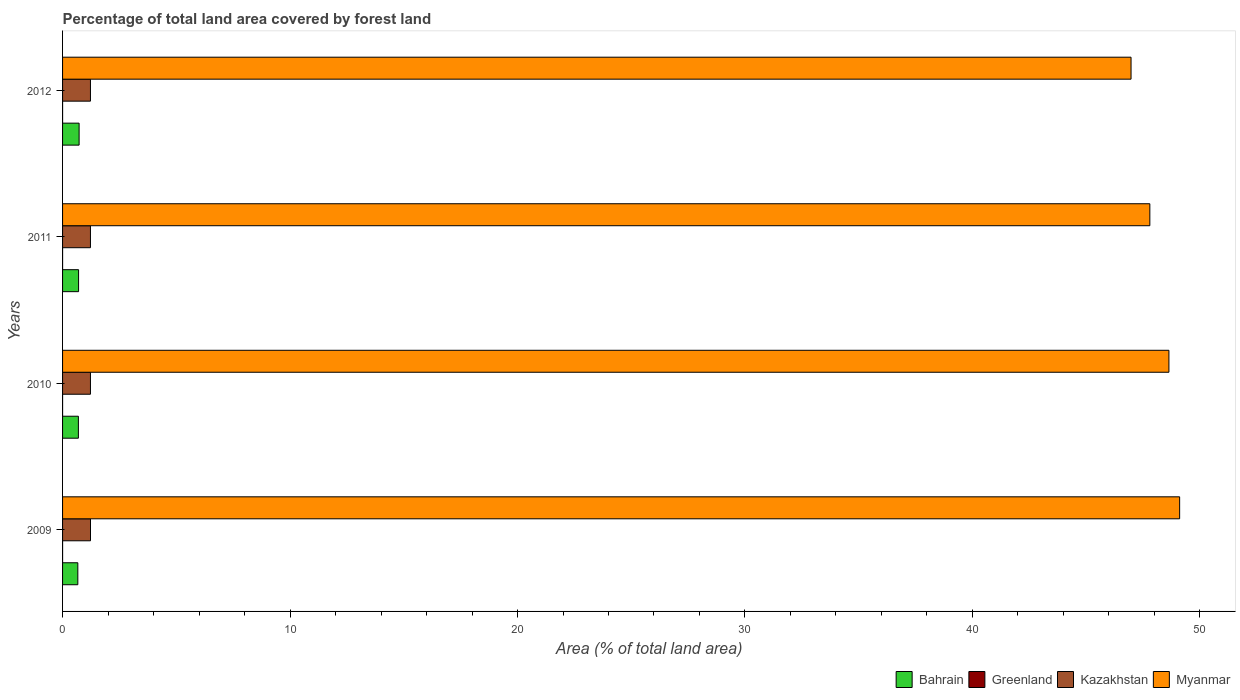How many different coloured bars are there?
Give a very brief answer. 4. How many bars are there on the 2nd tick from the top?
Provide a short and direct response. 4. How many bars are there on the 3rd tick from the bottom?
Give a very brief answer. 4. In how many cases, is the number of bars for a given year not equal to the number of legend labels?
Your answer should be very brief. 0. What is the percentage of forest land in Greenland in 2009?
Your answer should be compact. 0. Across all years, what is the maximum percentage of forest land in Myanmar?
Your response must be concise. 49.11. Across all years, what is the minimum percentage of forest land in Greenland?
Provide a short and direct response. 0. In which year was the percentage of forest land in Greenland maximum?
Offer a very short reply. 2009. What is the total percentage of forest land in Myanmar in the graph?
Give a very brief answer. 192.52. What is the difference between the percentage of forest land in Myanmar in 2009 and that in 2010?
Offer a very short reply. 0.47. What is the difference between the percentage of forest land in Greenland in 2011 and the percentage of forest land in Myanmar in 2012?
Offer a terse response. -46.97. What is the average percentage of forest land in Kazakhstan per year?
Your answer should be compact. 1.23. In the year 2009, what is the difference between the percentage of forest land in Kazakhstan and percentage of forest land in Bahrain?
Provide a succinct answer. 0.56. In how many years, is the percentage of forest land in Kazakhstan greater than 34 %?
Your response must be concise. 0. What is the ratio of the percentage of forest land in Bahrain in 2010 to that in 2011?
Your answer should be very brief. 0.99. What is the difference between the highest and the second highest percentage of forest land in Bahrain?
Keep it short and to the point. 0.02. What is the difference between the highest and the lowest percentage of forest land in Myanmar?
Keep it short and to the point. 2.14. Is it the case that in every year, the sum of the percentage of forest land in Bahrain and percentage of forest land in Kazakhstan is greater than the sum of percentage of forest land in Myanmar and percentage of forest land in Greenland?
Give a very brief answer. Yes. What does the 2nd bar from the top in 2009 represents?
Ensure brevity in your answer.  Kazakhstan. What does the 3rd bar from the bottom in 2011 represents?
Ensure brevity in your answer.  Kazakhstan. Is it the case that in every year, the sum of the percentage of forest land in Kazakhstan and percentage of forest land in Myanmar is greater than the percentage of forest land in Greenland?
Provide a succinct answer. Yes. How many years are there in the graph?
Your answer should be very brief. 4. What is the difference between two consecutive major ticks on the X-axis?
Give a very brief answer. 10. Are the values on the major ticks of X-axis written in scientific E-notation?
Provide a succinct answer. No. Does the graph contain any zero values?
Keep it short and to the point. No. Where does the legend appear in the graph?
Make the answer very short. Bottom right. How many legend labels are there?
Offer a terse response. 4. How are the legend labels stacked?
Make the answer very short. Horizontal. What is the title of the graph?
Make the answer very short. Percentage of total land area covered by forest land. What is the label or title of the X-axis?
Your answer should be compact. Area (% of total land area). What is the label or title of the Y-axis?
Offer a very short reply. Years. What is the Area (% of total land area) of Bahrain in 2009?
Give a very brief answer. 0.67. What is the Area (% of total land area) of Greenland in 2009?
Offer a terse response. 0. What is the Area (% of total land area) in Kazakhstan in 2009?
Offer a very short reply. 1.23. What is the Area (% of total land area) of Myanmar in 2009?
Your answer should be compact. 49.11. What is the Area (% of total land area) of Bahrain in 2010?
Provide a short and direct response. 0.7. What is the Area (% of total land area) in Greenland in 2010?
Make the answer very short. 0. What is the Area (% of total land area) of Kazakhstan in 2010?
Your answer should be very brief. 1.23. What is the Area (% of total land area) in Myanmar in 2010?
Provide a succinct answer. 48.64. What is the Area (% of total land area) of Bahrain in 2011?
Offer a very short reply. 0.7. What is the Area (% of total land area) of Greenland in 2011?
Make the answer very short. 0. What is the Area (% of total land area) in Kazakhstan in 2011?
Your answer should be compact. 1.23. What is the Area (% of total land area) in Myanmar in 2011?
Offer a terse response. 47.8. What is the Area (% of total land area) of Bahrain in 2012?
Offer a very short reply. 0.73. What is the Area (% of total land area) of Greenland in 2012?
Your response must be concise. 0. What is the Area (% of total land area) of Kazakhstan in 2012?
Make the answer very short. 1.23. What is the Area (% of total land area) in Myanmar in 2012?
Your answer should be compact. 46.97. Across all years, what is the maximum Area (% of total land area) in Bahrain?
Offer a very short reply. 0.73. Across all years, what is the maximum Area (% of total land area) in Greenland?
Your answer should be very brief. 0. Across all years, what is the maximum Area (% of total land area) of Kazakhstan?
Your answer should be compact. 1.23. Across all years, what is the maximum Area (% of total land area) in Myanmar?
Offer a very short reply. 49.11. Across all years, what is the minimum Area (% of total land area) in Bahrain?
Offer a very short reply. 0.67. Across all years, what is the minimum Area (% of total land area) in Greenland?
Your response must be concise. 0. Across all years, what is the minimum Area (% of total land area) in Kazakhstan?
Offer a terse response. 1.23. Across all years, what is the minimum Area (% of total land area) in Myanmar?
Offer a terse response. 46.97. What is the total Area (% of total land area) of Bahrain in the graph?
Offer a terse response. 2.8. What is the total Area (% of total land area) of Greenland in the graph?
Give a very brief answer. 0. What is the total Area (% of total land area) of Kazakhstan in the graph?
Offer a very short reply. 4.9. What is the total Area (% of total land area) in Myanmar in the graph?
Provide a succinct answer. 192.52. What is the difference between the Area (% of total land area) of Bahrain in 2009 and that in 2010?
Your answer should be compact. -0.02. What is the difference between the Area (% of total land area) of Kazakhstan in 2009 and that in 2010?
Give a very brief answer. 0. What is the difference between the Area (% of total land area) of Myanmar in 2009 and that in 2010?
Offer a terse response. 0.47. What is the difference between the Area (% of total land area) of Bahrain in 2009 and that in 2011?
Offer a terse response. -0.03. What is the difference between the Area (% of total land area) in Greenland in 2009 and that in 2011?
Provide a short and direct response. 0. What is the difference between the Area (% of total land area) in Kazakhstan in 2009 and that in 2011?
Ensure brevity in your answer.  0. What is the difference between the Area (% of total land area) in Myanmar in 2009 and that in 2011?
Your response must be concise. 1.31. What is the difference between the Area (% of total land area) of Bahrain in 2009 and that in 2012?
Your response must be concise. -0.06. What is the difference between the Area (% of total land area) of Greenland in 2009 and that in 2012?
Offer a very short reply. 0. What is the difference between the Area (% of total land area) of Kazakhstan in 2009 and that in 2012?
Your answer should be very brief. 0. What is the difference between the Area (% of total land area) of Myanmar in 2009 and that in 2012?
Keep it short and to the point. 2.14. What is the difference between the Area (% of total land area) of Bahrain in 2010 and that in 2011?
Your answer should be compact. -0.01. What is the difference between the Area (% of total land area) in Greenland in 2010 and that in 2011?
Offer a very short reply. 0. What is the difference between the Area (% of total land area) of Kazakhstan in 2010 and that in 2011?
Your response must be concise. 0. What is the difference between the Area (% of total land area) of Myanmar in 2010 and that in 2011?
Give a very brief answer. 0.84. What is the difference between the Area (% of total land area) in Bahrain in 2010 and that in 2012?
Your response must be concise. -0.03. What is the difference between the Area (% of total land area) of Kazakhstan in 2010 and that in 2012?
Ensure brevity in your answer.  0. What is the difference between the Area (% of total land area) in Myanmar in 2010 and that in 2012?
Your response must be concise. 1.66. What is the difference between the Area (% of total land area) of Bahrain in 2011 and that in 2012?
Ensure brevity in your answer.  -0.02. What is the difference between the Area (% of total land area) in Greenland in 2011 and that in 2012?
Your response must be concise. 0. What is the difference between the Area (% of total land area) in Kazakhstan in 2011 and that in 2012?
Your answer should be very brief. 0. What is the difference between the Area (% of total land area) of Myanmar in 2011 and that in 2012?
Ensure brevity in your answer.  0.83. What is the difference between the Area (% of total land area) of Bahrain in 2009 and the Area (% of total land area) of Greenland in 2010?
Your response must be concise. 0.67. What is the difference between the Area (% of total land area) in Bahrain in 2009 and the Area (% of total land area) in Kazakhstan in 2010?
Provide a short and direct response. -0.55. What is the difference between the Area (% of total land area) of Bahrain in 2009 and the Area (% of total land area) of Myanmar in 2010?
Your response must be concise. -47.97. What is the difference between the Area (% of total land area) in Greenland in 2009 and the Area (% of total land area) in Kazakhstan in 2010?
Your answer should be very brief. -1.23. What is the difference between the Area (% of total land area) of Greenland in 2009 and the Area (% of total land area) of Myanmar in 2010?
Provide a short and direct response. -48.64. What is the difference between the Area (% of total land area) of Kazakhstan in 2009 and the Area (% of total land area) of Myanmar in 2010?
Make the answer very short. -47.41. What is the difference between the Area (% of total land area) in Bahrain in 2009 and the Area (% of total land area) in Greenland in 2011?
Your answer should be very brief. 0.67. What is the difference between the Area (% of total land area) in Bahrain in 2009 and the Area (% of total land area) in Kazakhstan in 2011?
Provide a short and direct response. -0.55. What is the difference between the Area (% of total land area) of Bahrain in 2009 and the Area (% of total land area) of Myanmar in 2011?
Make the answer very short. -47.13. What is the difference between the Area (% of total land area) in Greenland in 2009 and the Area (% of total land area) in Kazakhstan in 2011?
Offer a very short reply. -1.23. What is the difference between the Area (% of total land area) of Greenland in 2009 and the Area (% of total land area) of Myanmar in 2011?
Your response must be concise. -47.8. What is the difference between the Area (% of total land area) in Kazakhstan in 2009 and the Area (% of total land area) in Myanmar in 2011?
Your answer should be very brief. -46.57. What is the difference between the Area (% of total land area) of Bahrain in 2009 and the Area (% of total land area) of Greenland in 2012?
Offer a very short reply. 0.67. What is the difference between the Area (% of total land area) of Bahrain in 2009 and the Area (% of total land area) of Kazakhstan in 2012?
Ensure brevity in your answer.  -0.55. What is the difference between the Area (% of total land area) of Bahrain in 2009 and the Area (% of total land area) of Myanmar in 2012?
Make the answer very short. -46.3. What is the difference between the Area (% of total land area) of Greenland in 2009 and the Area (% of total land area) of Kazakhstan in 2012?
Keep it short and to the point. -1.23. What is the difference between the Area (% of total land area) in Greenland in 2009 and the Area (% of total land area) in Myanmar in 2012?
Provide a short and direct response. -46.97. What is the difference between the Area (% of total land area) of Kazakhstan in 2009 and the Area (% of total land area) of Myanmar in 2012?
Ensure brevity in your answer.  -45.74. What is the difference between the Area (% of total land area) of Bahrain in 2010 and the Area (% of total land area) of Greenland in 2011?
Give a very brief answer. 0.69. What is the difference between the Area (% of total land area) in Bahrain in 2010 and the Area (% of total land area) in Kazakhstan in 2011?
Offer a very short reply. -0.53. What is the difference between the Area (% of total land area) in Bahrain in 2010 and the Area (% of total land area) in Myanmar in 2011?
Your response must be concise. -47.1. What is the difference between the Area (% of total land area) of Greenland in 2010 and the Area (% of total land area) of Kazakhstan in 2011?
Keep it short and to the point. -1.23. What is the difference between the Area (% of total land area) in Greenland in 2010 and the Area (% of total land area) in Myanmar in 2011?
Ensure brevity in your answer.  -47.8. What is the difference between the Area (% of total land area) in Kazakhstan in 2010 and the Area (% of total land area) in Myanmar in 2011?
Your response must be concise. -46.57. What is the difference between the Area (% of total land area) in Bahrain in 2010 and the Area (% of total land area) in Greenland in 2012?
Your answer should be compact. 0.69. What is the difference between the Area (% of total land area) of Bahrain in 2010 and the Area (% of total land area) of Kazakhstan in 2012?
Your answer should be compact. -0.53. What is the difference between the Area (% of total land area) of Bahrain in 2010 and the Area (% of total land area) of Myanmar in 2012?
Keep it short and to the point. -46.28. What is the difference between the Area (% of total land area) of Greenland in 2010 and the Area (% of total land area) of Kazakhstan in 2012?
Provide a succinct answer. -1.23. What is the difference between the Area (% of total land area) of Greenland in 2010 and the Area (% of total land area) of Myanmar in 2012?
Ensure brevity in your answer.  -46.97. What is the difference between the Area (% of total land area) in Kazakhstan in 2010 and the Area (% of total land area) in Myanmar in 2012?
Your answer should be compact. -45.75. What is the difference between the Area (% of total land area) in Bahrain in 2011 and the Area (% of total land area) in Greenland in 2012?
Provide a short and direct response. 0.7. What is the difference between the Area (% of total land area) in Bahrain in 2011 and the Area (% of total land area) in Kazakhstan in 2012?
Offer a terse response. -0.52. What is the difference between the Area (% of total land area) of Bahrain in 2011 and the Area (% of total land area) of Myanmar in 2012?
Your answer should be very brief. -46.27. What is the difference between the Area (% of total land area) of Greenland in 2011 and the Area (% of total land area) of Kazakhstan in 2012?
Keep it short and to the point. -1.23. What is the difference between the Area (% of total land area) of Greenland in 2011 and the Area (% of total land area) of Myanmar in 2012?
Offer a terse response. -46.97. What is the difference between the Area (% of total land area) in Kazakhstan in 2011 and the Area (% of total land area) in Myanmar in 2012?
Your answer should be compact. -45.75. What is the average Area (% of total land area) in Bahrain per year?
Your answer should be compact. 0.7. What is the average Area (% of total land area) in Greenland per year?
Your response must be concise. 0. What is the average Area (% of total land area) in Kazakhstan per year?
Offer a terse response. 1.23. What is the average Area (% of total land area) of Myanmar per year?
Your response must be concise. 48.13. In the year 2009, what is the difference between the Area (% of total land area) in Bahrain and Area (% of total land area) in Greenland?
Give a very brief answer. 0.67. In the year 2009, what is the difference between the Area (% of total land area) in Bahrain and Area (% of total land area) in Kazakhstan?
Give a very brief answer. -0.56. In the year 2009, what is the difference between the Area (% of total land area) in Bahrain and Area (% of total land area) in Myanmar?
Ensure brevity in your answer.  -48.44. In the year 2009, what is the difference between the Area (% of total land area) in Greenland and Area (% of total land area) in Kazakhstan?
Offer a very short reply. -1.23. In the year 2009, what is the difference between the Area (% of total land area) in Greenland and Area (% of total land area) in Myanmar?
Give a very brief answer. -49.11. In the year 2009, what is the difference between the Area (% of total land area) of Kazakhstan and Area (% of total land area) of Myanmar?
Offer a terse response. -47.88. In the year 2010, what is the difference between the Area (% of total land area) of Bahrain and Area (% of total land area) of Greenland?
Make the answer very short. 0.69. In the year 2010, what is the difference between the Area (% of total land area) in Bahrain and Area (% of total land area) in Kazakhstan?
Make the answer very short. -0.53. In the year 2010, what is the difference between the Area (% of total land area) of Bahrain and Area (% of total land area) of Myanmar?
Provide a succinct answer. -47.94. In the year 2010, what is the difference between the Area (% of total land area) of Greenland and Area (% of total land area) of Kazakhstan?
Your response must be concise. -1.23. In the year 2010, what is the difference between the Area (% of total land area) of Greenland and Area (% of total land area) of Myanmar?
Keep it short and to the point. -48.64. In the year 2010, what is the difference between the Area (% of total land area) in Kazakhstan and Area (% of total land area) in Myanmar?
Give a very brief answer. -47.41. In the year 2011, what is the difference between the Area (% of total land area) in Bahrain and Area (% of total land area) in Greenland?
Ensure brevity in your answer.  0.7. In the year 2011, what is the difference between the Area (% of total land area) in Bahrain and Area (% of total land area) in Kazakhstan?
Your answer should be compact. -0.52. In the year 2011, what is the difference between the Area (% of total land area) in Bahrain and Area (% of total land area) in Myanmar?
Your answer should be compact. -47.09. In the year 2011, what is the difference between the Area (% of total land area) of Greenland and Area (% of total land area) of Kazakhstan?
Offer a very short reply. -1.23. In the year 2011, what is the difference between the Area (% of total land area) in Greenland and Area (% of total land area) in Myanmar?
Provide a short and direct response. -47.8. In the year 2011, what is the difference between the Area (% of total land area) in Kazakhstan and Area (% of total land area) in Myanmar?
Your response must be concise. -46.57. In the year 2012, what is the difference between the Area (% of total land area) of Bahrain and Area (% of total land area) of Greenland?
Your answer should be compact. 0.73. In the year 2012, what is the difference between the Area (% of total land area) of Bahrain and Area (% of total land area) of Kazakhstan?
Ensure brevity in your answer.  -0.5. In the year 2012, what is the difference between the Area (% of total land area) of Bahrain and Area (% of total land area) of Myanmar?
Ensure brevity in your answer.  -46.25. In the year 2012, what is the difference between the Area (% of total land area) in Greenland and Area (% of total land area) in Kazakhstan?
Your response must be concise. -1.23. In the year 2012, what is the difference between the Area (% of total land area) of Greenland and Area (% of total land area) of Myanmar?
Keep it short and to the point. -46.97. In the year 2012, what is the difference between the Area (% of total land area) in Kazakhstan and Area (% of total land area) in Myanmar?
Ensure brevity in your answer.  -45.75. What is the ratio of the Area (% of total land area) in Bahrain in 2009 to that in 2010?
Your answer should be very brief. 0.96. What is the ratio of the Area (% of total land area) of Greenland in 2009 to that in 2010?
Give a very brief answer. 1. What is the ratio of the Area (% of total land area) in Myanmar in 2009 to that in 2010?
Ensure brevity in your answer.  1.01. What is the ratio of the Area (% of total land area) in Bahrain in 2009 to that in 2011?
Offer a very short reply. 0.95. What is the ratio of the Area (% of total land area) in Greenland in 2009 to that in 2011?
Offer a very short reply. 1. What is the ratio of the Area (% of total land area) in Myanmar in 2009 to that in 2011?
Ensure brevity in your answer.  1.03. What is the ratio of the Area (% of total land area) of Bahrain in 2009 to that in 2012?
Keep it short and to the point. 0.92. What is the ratio of the Area (% of total land area) of Myanmar in 2009 to that in 2012?
Your answer should be compact. 1.05. What is the ratio of the Area (% of total land area) in Bahrain in 2010 to that in 2011?
Offer a terse response. 0.99. What is the ratio of the Area (% of total land area) in Myanmar in 2010 to that in 2011?
Make the answer very short. 1.02. What is the ratio of the Area (% of total land area) of Bahrain in 2010 to that in 2012?
Give a very brief answer. 0.96. What is the ratio of the Area (% of total land area) of Myanmar in 2010 to that in 2012?
Your answer should be compact. 1.04. What is the ratio of the Area (% of total land area) of Bahrain in 2011 to that in 2012?
Make the answer very short. 0.97. What is the ratio of the Area (% of total land area) of Greenland in 2011 to that in 2012?
Your response must be concise. 1. What is the ratio of the Area (% of total land area) in Kazakhstan in 2011 to that in 2012?
Your answer should be compact. 1. What is the ratio of the Area (% of total land area) of Myanmar in 2011 to that in 2012?
Your response must be concise. 1.02. What is the difference between the highest and the second highest Area (% of total land area) in Bahrain?
Make the answer very short. 0.02. What is the difference between the highest and the second highest Area (% of total land area) in Greenland?
Offer a very short reply. 0. What is the difference between the highest and the second highest Area (% of total land area) in Kazakhstan?
Provide a succinct answer. 0. What is the difference between the highest and the second highest Area (% of total land area) of Myanmar?
Offer a terse response. 0.47. What is the difference between the highest and the lowest Area (% of total land area) of Bahrain?
Offer a very short reply. 0.06. What is the difference between the highest and the lowest Area (% of total land area) of Greenland?
Keep it short and to the point. 0. What is the difference between the highest and the lowest Area (% of total land area) in Kazakhstan?
Provide a short and direct response. 0. What is the difference between the highest and the lowest Area (% of total land area) in Myanmar?
Keep it short and to the point. 2.14. 